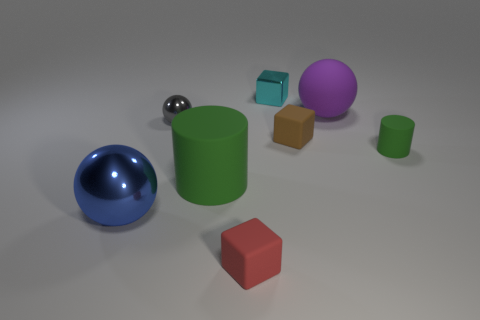Subtract all tiny matte cubes. How many cubes are left? 1 Add 1 big matte blocks. How many objects exist? 9 Subtract all cyan blocks. How many blocks are left? 2 Subtract all spheres. How many objects are left? 5 Subtract 1 cylinders. How many cylinders are left? 1 Subtract all brown cylinders. Subtract all purple spheres. How many cylinders are left? 2 Subtract all gray cylinders. How many gray spheres are left? 1 Subtract all tiny brown objects. Subtract all big green things. How many objects are left? 6 Add 2 purple balls. How many purple balls are left? 3 Add 2 brown things. How many brown things exist? 3 